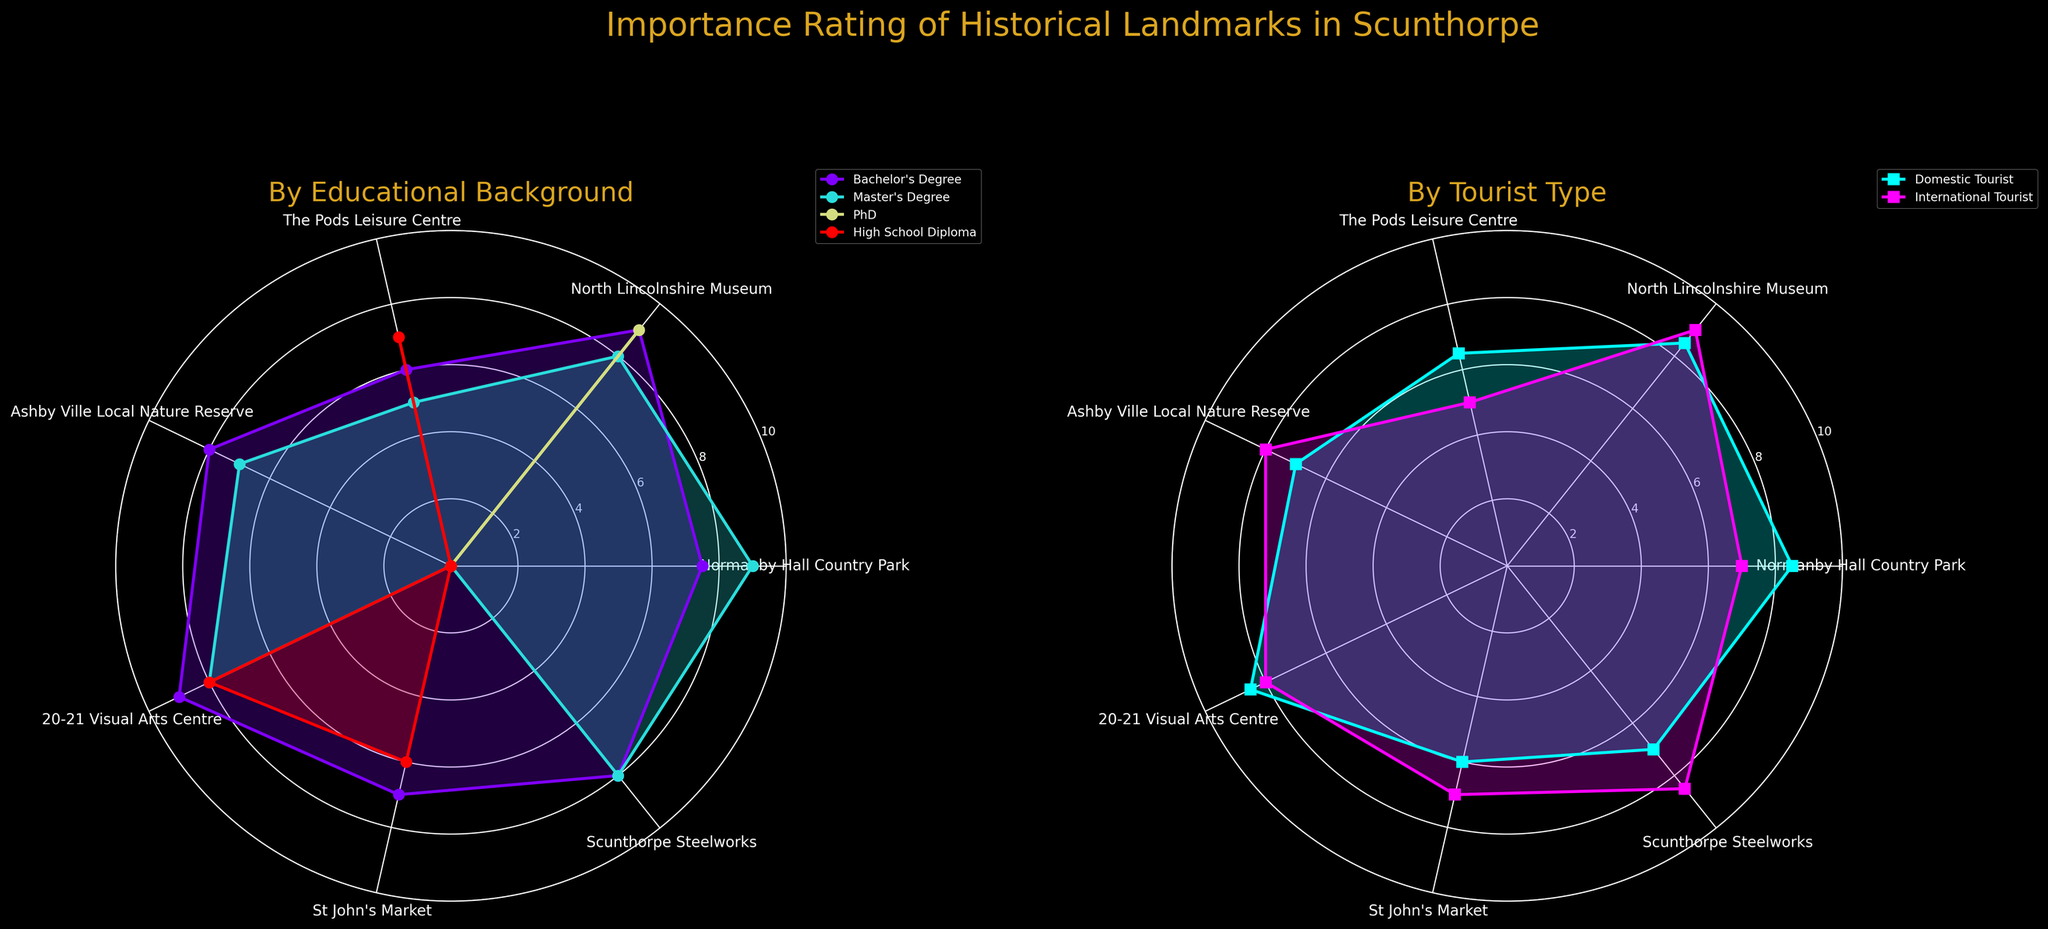What is the title of the plot? The title can be found at the top of the figure, in large text. It gives an overview of what the plot is about.
Answer: Importance Rating of Historical Landmarks in Scunthorpe Which historical landmark has the highest importance rating for PhD international tourists? Look at the radar chart corresponding to tourist types. Identify the color representing PhD international tourists and then find the highest point on the chart where this color is represented.
Answer: North Lincolnshire Museum Which educational background has the highest importance rating for 20-21 Visual Arts Centre? Refer to the radar chart for educational backgrounds. Identify the segment representing 20-21 Visual Arts Centre, and then find the highest value among all the educational backgrounds.
Answer: Bachelor's Degree Do international tourists or domestic tourists rate Scunthorpe Steelworks higher? Check the radar chart associated with tourist types. Compare the height of the data points at the Scunthorpe Steelworks position for international tourists and domestic tourists.
Answer: International tourists Which educational background considers St John's Market the least important? Look at the radar chart by educational background. Identify the landmark St John's Market, and see which educational background has the lowest importance rating.
Answer: High School Diploma What is the average importance rating of The Pods Leisure Centre by all educational backgrounds? Locate The Pods Leisure Centre on the radar chart for educational backgrounds. Note the importance ratings for each background, sum these ratings, then divide by the number of backgrounds to get the average.
Answer: (6 + 5 + 7) / 3 = 6 Which tourist type finds the importance rating of Normanby Hall Country Park higher, Domestic Tourist or International Tourist? Compare the importance rating for Normanby Hall Country Park between domestic tourists and international tourists on the radar chart specific to tourist types.
Answer: Domestic Tourist Among Bachelor's Degree and Master's Degree educational backgrounds, which considers the 20-21 Visual Arts Centre more important? Check the radar chart for educational backgrounds. Compare the rating given to the 20-21 Visual Arts Centre by Bachelor's Degree and Master's Degree holders.
Answer: Bachelor's Degree Which historical landmark has a rating exactly equal to 9 for Domestic Tourists? Refer to the radar chart by tourist types, and locate the data points for domestic tourists. Identify the landmarks where the data points exactly hit the value 9.
Answer: North Lincolnshire Museum and 20-21 Visual Arts Centre 